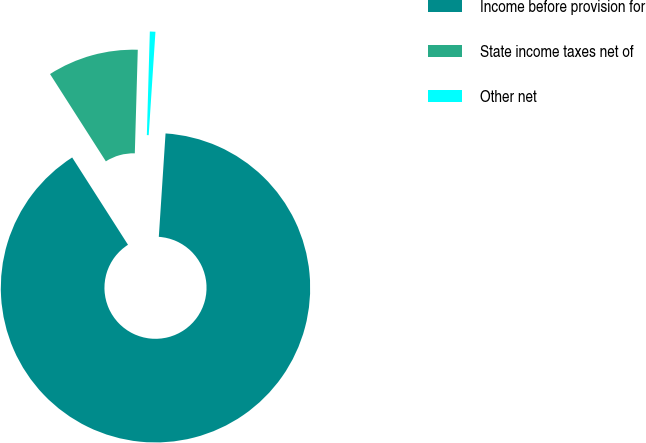Convert chart to OTSL. <chart><loc_0><loc_0><loc_500><loc_500><pie_chart><fcel>Income before provision for<fcel>State income taxes net of<fcel>Other net<nl><fcel>89.91%<fcel>9.51%<fcel>0.58%<nl></chart> 